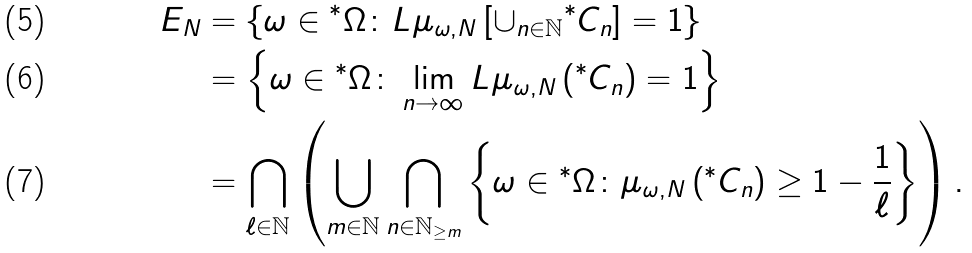<formula> <loc_0><loc_0><loc_500><loc_500>E _ { N } & = \left \{ \omega \in { ^ { * } } \Omega \colon L \mu _ { \omega , N } \left [ \cup _ { n \in \mathbb { N } } { ^ { * } } C _ { n } \right ] = 1 \right \} \\ & = \left \{ \omega \in { ^ { * } } \Omega \colon \lim _ { n \rightarrow \infty } L \mu _ { \omega , N } \left ( { ^ { * } } C _ { n } \right ) = 1 \right \} \\ & = \bigcap _ { \ell \in \mathbb { N } } \left ( \bigcup _ { m \in \mathbb { N } } \bigcap _ { n \in \mathbb { N } _ { \geq m } } \left \{ \omega \in { ^ { * } } \Omega \colon \mu _ { \omega , N } \left ( { ^ { * } } C _ { n } \right ) \geq 1 - \frac { 1 } { \ell } \right \} \right ) .</formula> 